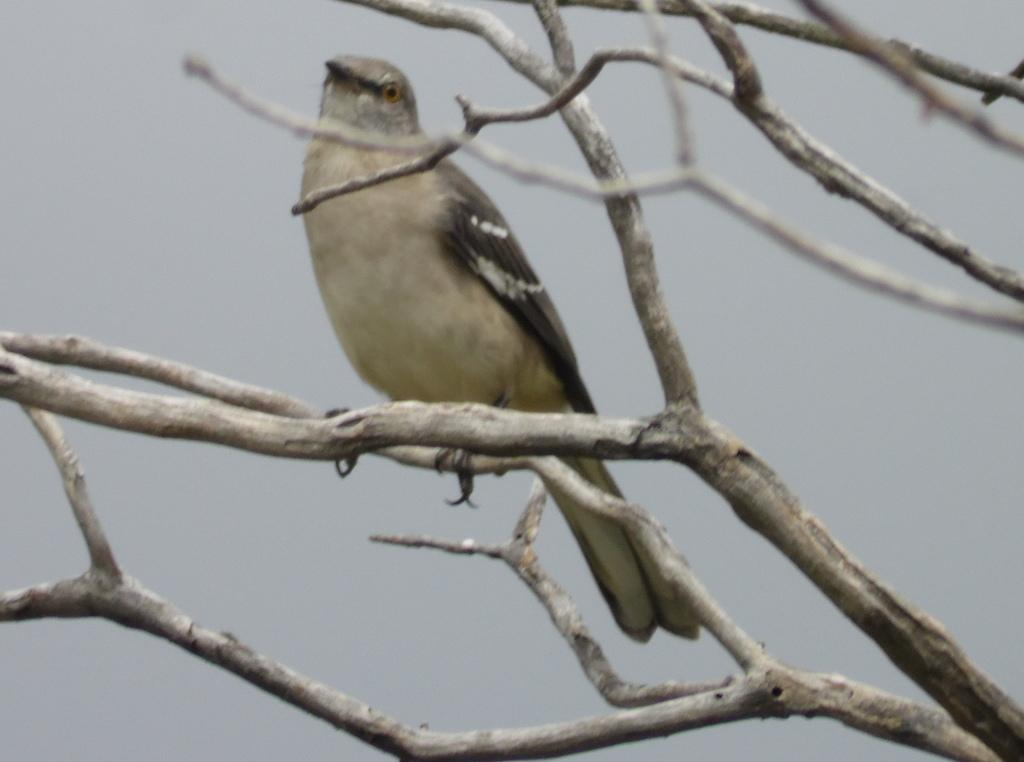What type of animal is in the image? There is a bird in the image. Where is the bird located? The bird is on a branch of a tree. What can be seen in the background of the image? The sky is visible in the background of the image. How many rings are the bird wearing in the image? There are no rings visible on the bird in the image. What type of station is the bird using to perch on the branch? The bird is naturally perched on the branch and does not require a station to do so. 